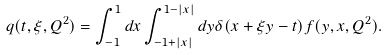<formula> <loc_0><loc_0><loc_500><loc_500>q ( t , \xi , Q ^ { 2 } ) = \int _ { - 1 } ^ { 1 } d x \int _ { - 1 + | x | } ^ { 1 - | x | } d y \delta ( x + \xi y - t ) f ( y , x , Q ^ { 2 } ) .</formula> 